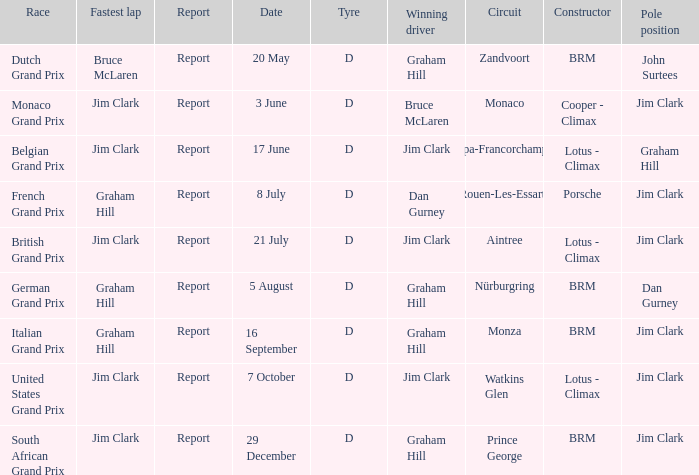Can you parse all the data within this table? {'header': ['Race', 'Fastest lap', 'Report', 'Date', 'Tyre', 'Winning driver', 'Circuit', 'Constructor', 'Pole position'], 'rows': [['Dutch Grand Prix', 'Bruce McLaren', 'Report', '20 May', 'D', 'Graham Hill', 'Zandvoort', 'BRM', 'John Surtees'], ['Monaco Grand Prix', 'Jim Clark', 'Report', '3 June', 'D', 'Bruce McLaren', 'Monaco', 'Cooper - Climax', 'Jim Clark'], ['Belgian Grand Prix', 'Jim Clark', 'Report', '17 June', 'D', 'Jim Clark', 'Spa-Francorchamps', 'Lotus - Climax', 'Graham Hill'], ['French Grand Prix', 'Graham Hill', 'Report', '8 July', 'D', 'Dan Gurney', 'Rouen-Les-Essarts', 'Porsche', 'Jim Clark'], ['British Grand Prix', 'Jim Clark', 'Report', '21 July', 'D', 'Jim Clark', 'Aintree', 'Lotus - Climax', 'Jim Clark'], ['German Grand Prix', 'Graham Hill', 'Report', '5 August', 'D', 'Graham Hill', 'Nürburgring', 'BRM', 'Dan Gurney'], ['Italian Grand Prix', 'Graham Hill', 'Report', '16 September', 'D', 'Graham Hill', 'Monza', 'BRM', 'Jim Clark'], ['United States Grand Prix', 'Jim Clark', 'Report', '7 October', 'D', 'Jim Clark', 'Watkins Glen', 'Lotus - Climax', 'Jim Clark'], ['South African Grand Prix', 'Jim Clark', 'Report', '29 December', 'D', 'Graham Hill', 'Prince George', 'BRM', 'Jim Clark']]} What is the tyre for the circuit of Prince George, which had Jim Clark as the fastest lap? D. 